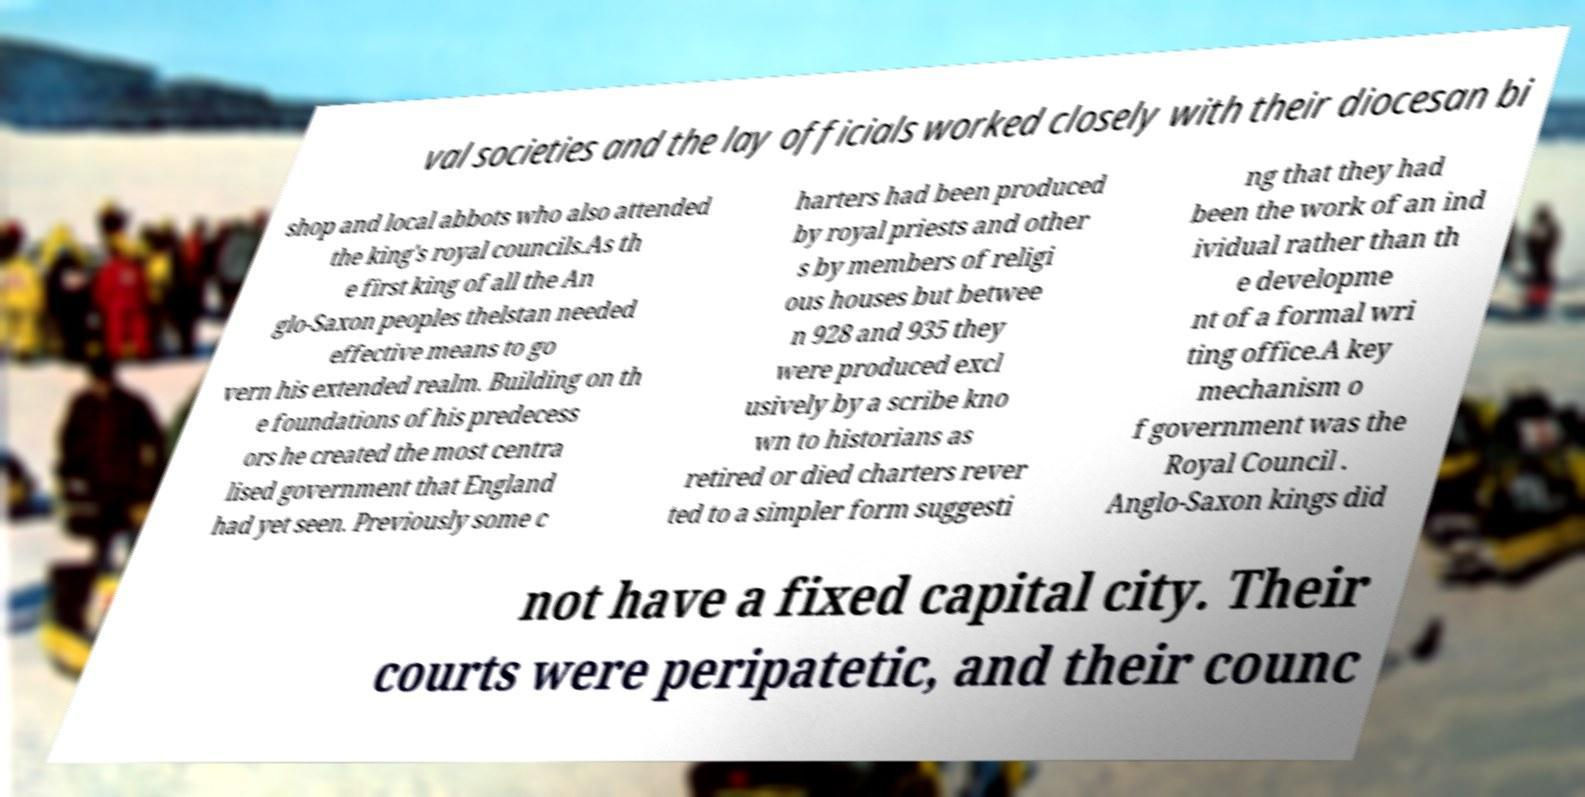Can you read and provide the text displayed in the image?This photo seems to have some interesting text. Can you extract and type it out for me? val societies and the lay officials worked closely with their diocesan bi shop and local abbots who also attended the king's royal councils.As th e first king of all the An glo-Saxon peoples thelstan needed effective means to go vern his extended realm. Building on th e foundations of his predecess ors he created the most centra lised government that England had yet seen. Previously some c harters had been produced by royal priests and other s by members of religi ous houses but betwee n 928 and 935 they were produced excl usively by a scribe kno wn to historians as retired or died charters rever ted to a simpler form suggesti ng that they had been the work of an ind ividual rather than th e developme nt of a formal wri ting office.A key mechanism o f government was the Royal Council . Anglo-Saxon kings did not have a fixed capital city. Their courts were peripatetic, and their counc 